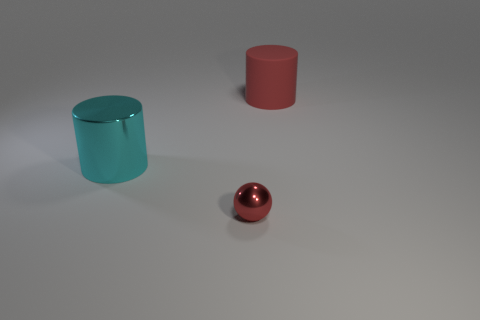Is there anything else that has the same size as the ball?
Provide a short and direct response. No. How many objects are large cyan matte cylinders or cylinders that are in front of the big red matte cylinder?
Give a very brief answer. 1. What number of other objects are the same shape as the large red matte thing?
Your answer should be very brief. 1. Are there fewer large metallic things behind the cyan cylinder than large things right of the tiny object?
Your answer should be very brief. Yes. Are there any other things that are the same material as the red cylinder?
Provide a short and direct response. No. What is the shape of the object that is made of the same material as the sphere?
Give a very brief answer. Cylinder. Is there any other thing that has the same color as the big shiny thing?
Give a very brief answer. No. There is a large object to the left of the cylinder that is behind the large cyan metal cylinder; what color is it?
Offer a very short reply. Cyan. There is a large cylinder that is to the left of the large cylinder to the right of the shiny thing that is behind the red ball; what is it made of?
Keep it short and to the point. Metal. What number of red matte objects are the same size as the red shiny ball?
Offer a very short reply. 0. 